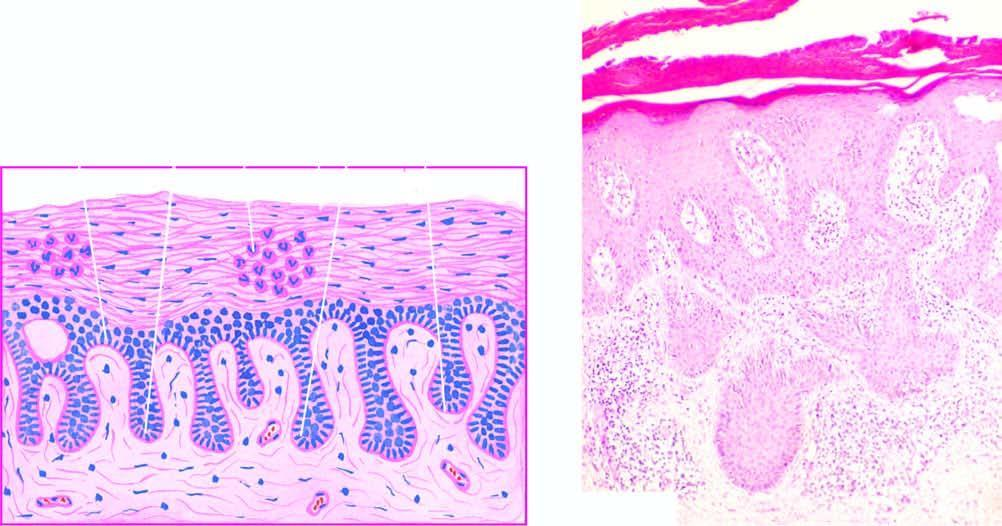s there regular elongation of the rete ridges with thickening of their lower portion?
Answer the question using a single word or phrase. Yes 